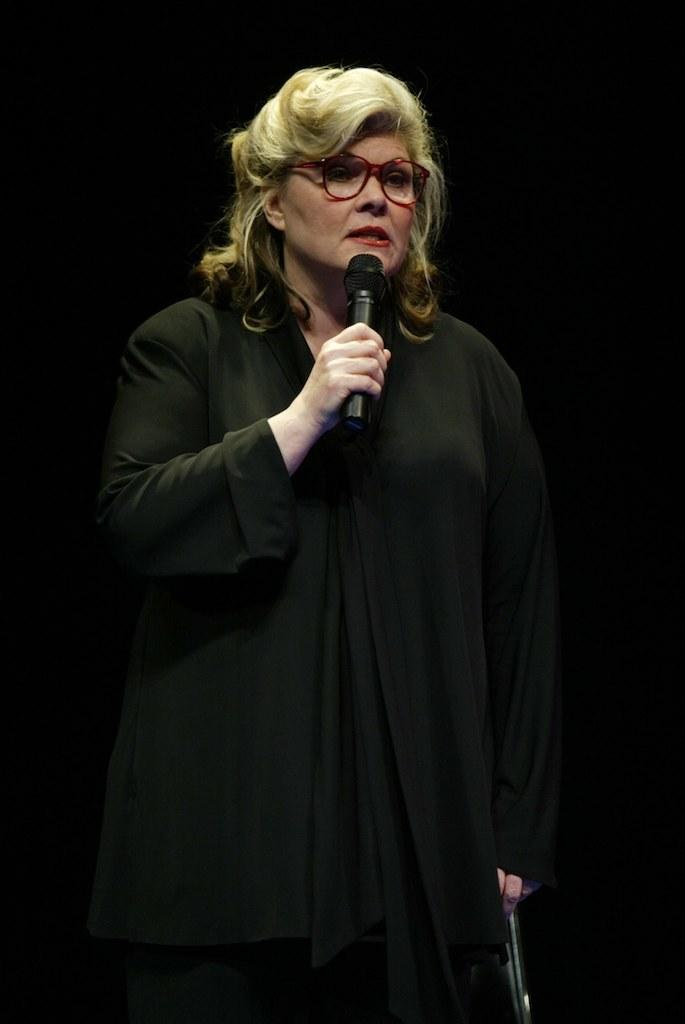What is the person in the image doing? The person is standing in the image and holding a microphone. What is the person wearing? The person is wearing a black color dress. What can be seen in the background of the image? The background of the image is black. How many stomachs does the person have in the image? The person's stomach is not visible in the image, so it cannot be determined how many stomachs they have. Is the person wearing a cap in the image? There is no cap visible on the person in the image. 